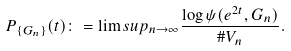<formula> <loc_0><loc_0><loc_500><loc_500>P _ { \{ G _ { n } \} } ( t ) \colon = \lim s u p _ { n \to \infty } \frac { \log \psi ( e ^ { 2 t } , G _ { n } ) } { \# V _ { n } } .</formula> 